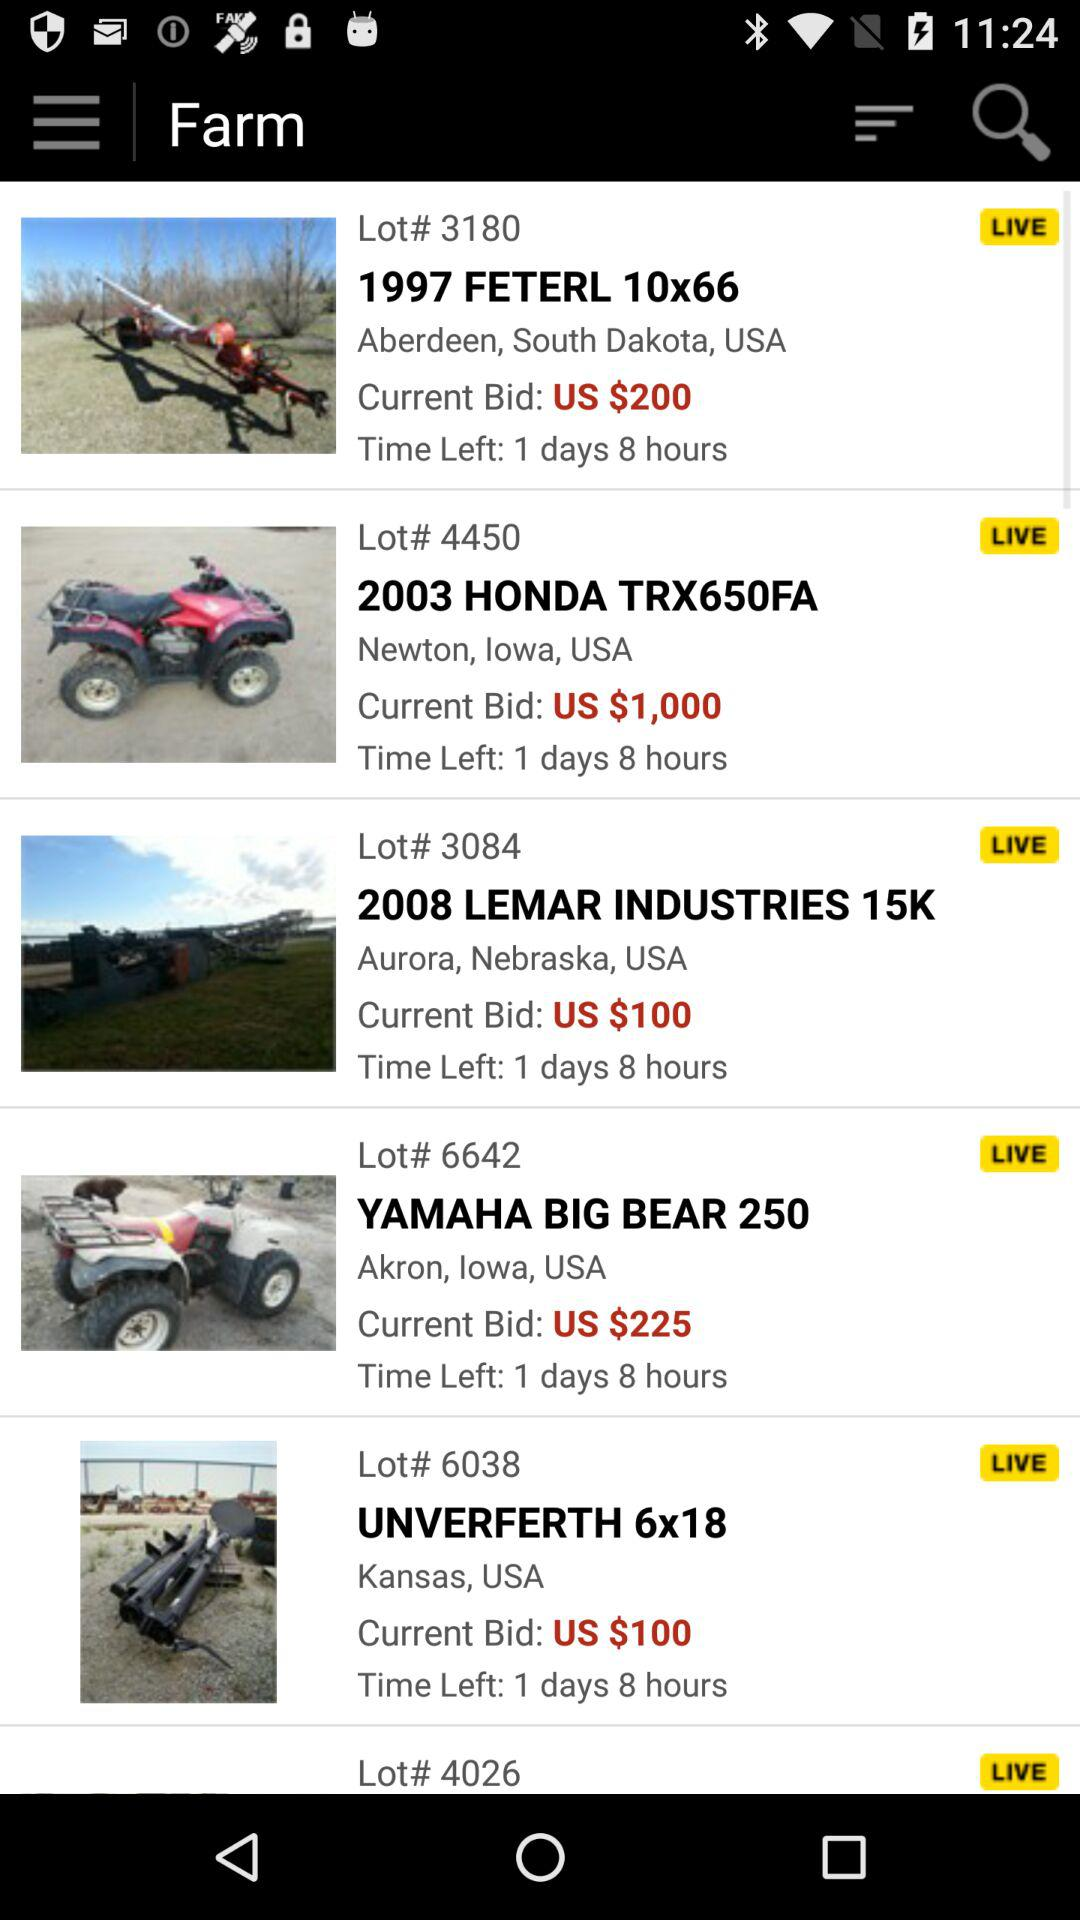When will the YAMAHA BIG BEAR 250's bid come to an end? It will come to an end after 1 day and 8 days. 